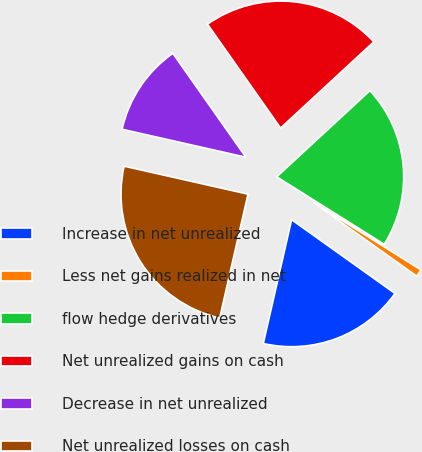<chart> <loc_0><loc_0><loc_500><loc_500><pie_chart><fcel>Increase in net unrealized<fcel>Less net gains realized in net<fcel>flow hedge derivatives<fcel>Net unrealized gains on cash<fcel>Decrease in net unrealized<fcel>Net unrealized losses on cash<nl><fcel>18.72%<fcel>0.94%<fcel>20.8%<fcel>22.88%<fcel>11.71%<fcel>24.96%<nl></chart> 